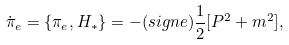<formula> <loc_0><loc_0><loc_500><loc_500>\dot { \pi } _ { e } = \{ \pi _ { e } , H _ { * } \} = - ( s i g n e ) \frac { 1 } { 2 } [ P ^ { 2 } + m ^ { 2 } ] ,</formula> 